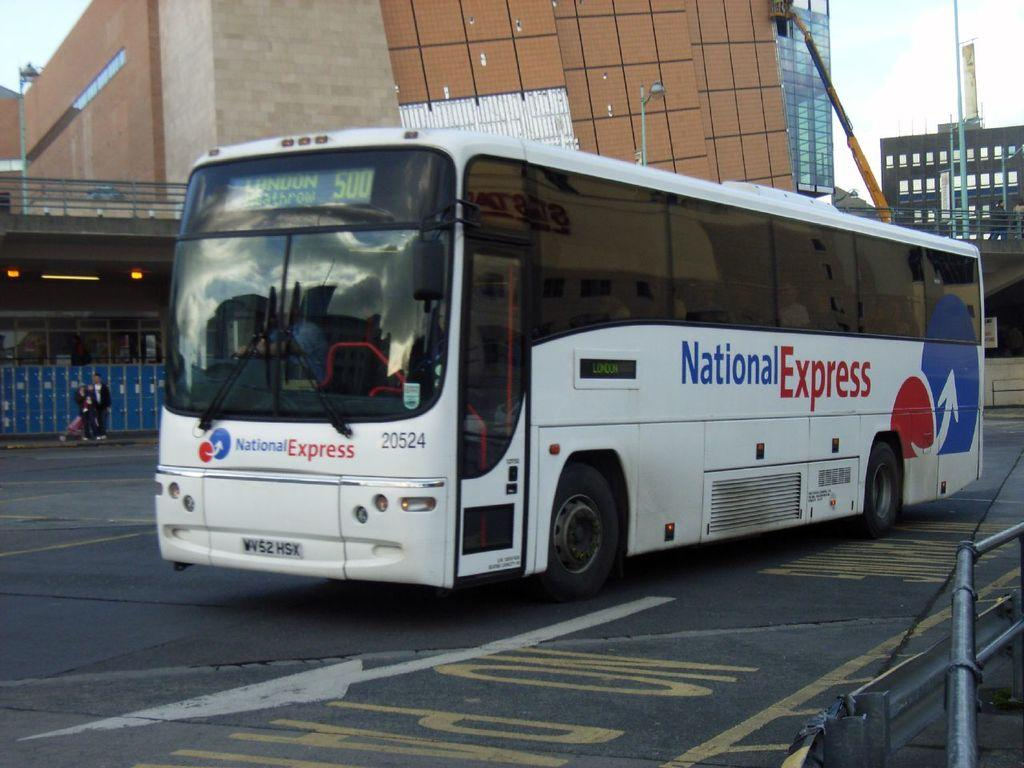<image>
Describe the image concisely. A National Express bus that is driving to London. 